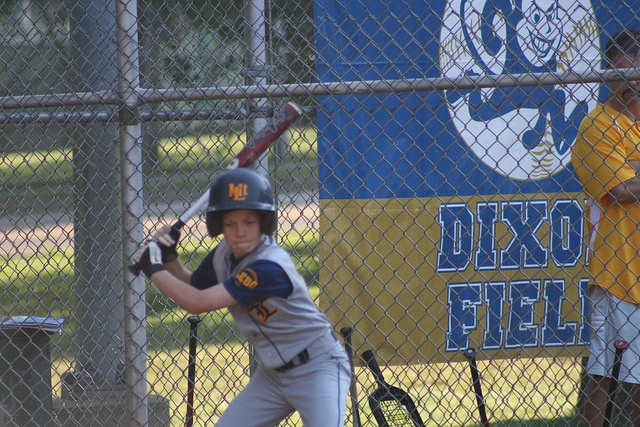Describe the objects in this image and their specific colors. I can see people in black, gray, and navy tones, people in black, olive, and gray tones, baseball bat in black, gray, purple, and darkgray tones, and book in black, gray, and darkgray tones in this image. 